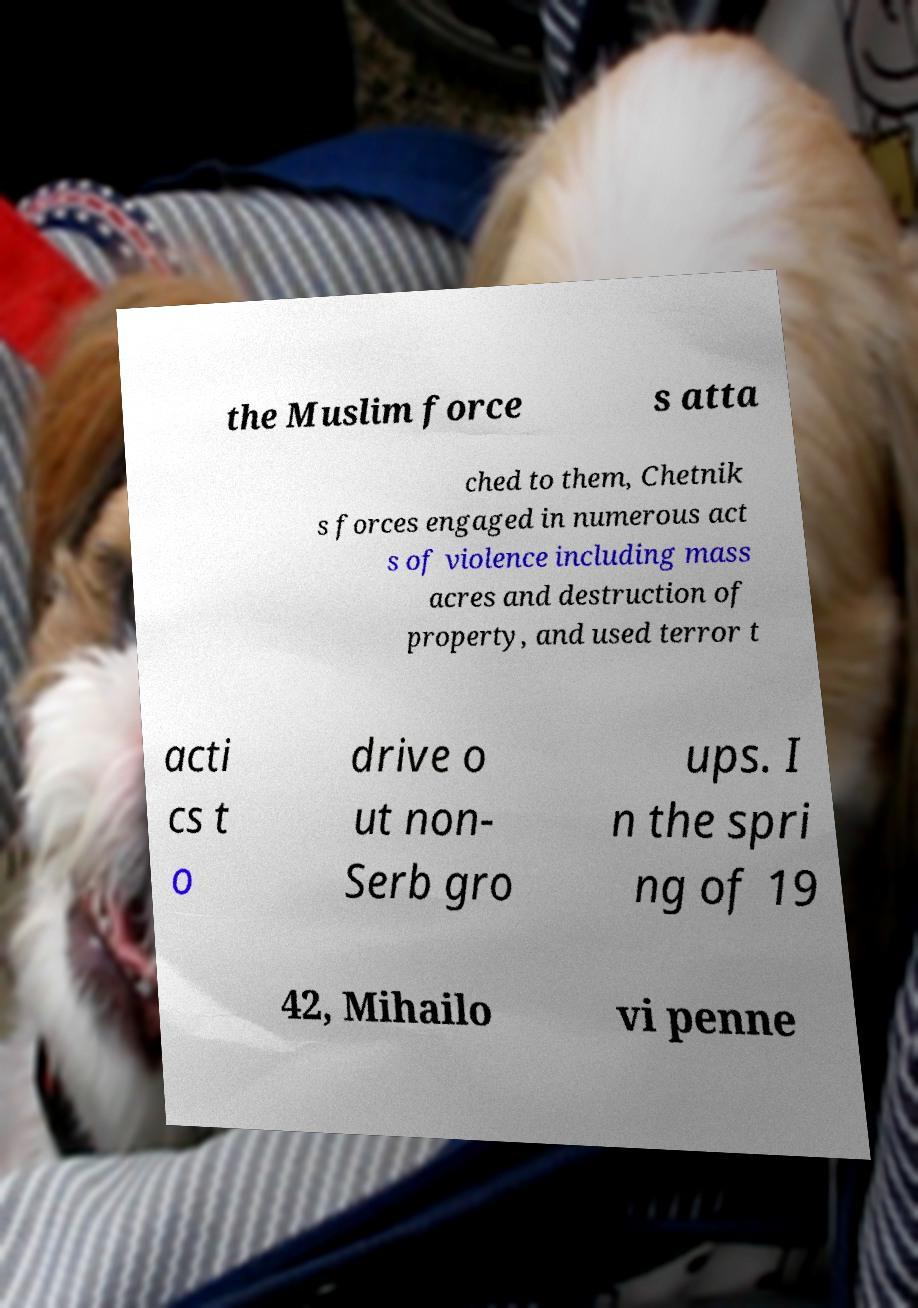What messages or text are displayed in this image? I need them in a readable, typed format. the Muslim force s atta ched to them, Chetnik s forces engaged in numerous act s of violence including mass acres and destruction of property, and used terror t acti cs t o drive o ut non- Serb gro ups. I n the spri ng of 19 42, Mihailo vi penne 